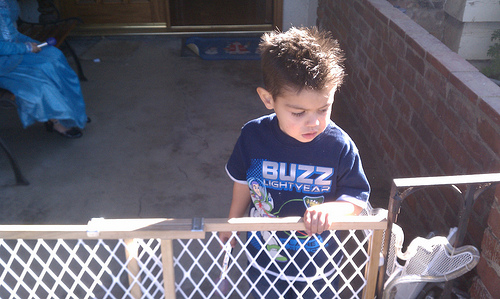<image>
Can you confirm if the child is behind the baby gate? Yes. From this viewpoint, the child is positioned behind the baby gate, with the baby gate partially or fully occluding the child. 